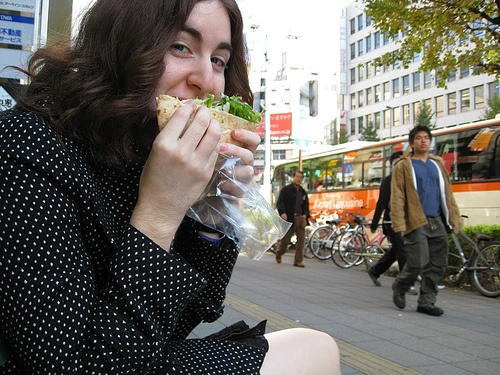Describe the objects in this image and their specific colors. I can see people in darkgray, black, lightgray, and gray tones, bus in darkgray, tan, black, ivory, and gray tones, people in darkgray, black, olive, and gray tones, sandwich in darkgray, tan, and darkgreen tones, and people in darkgray, black, and gray tones in this image. 